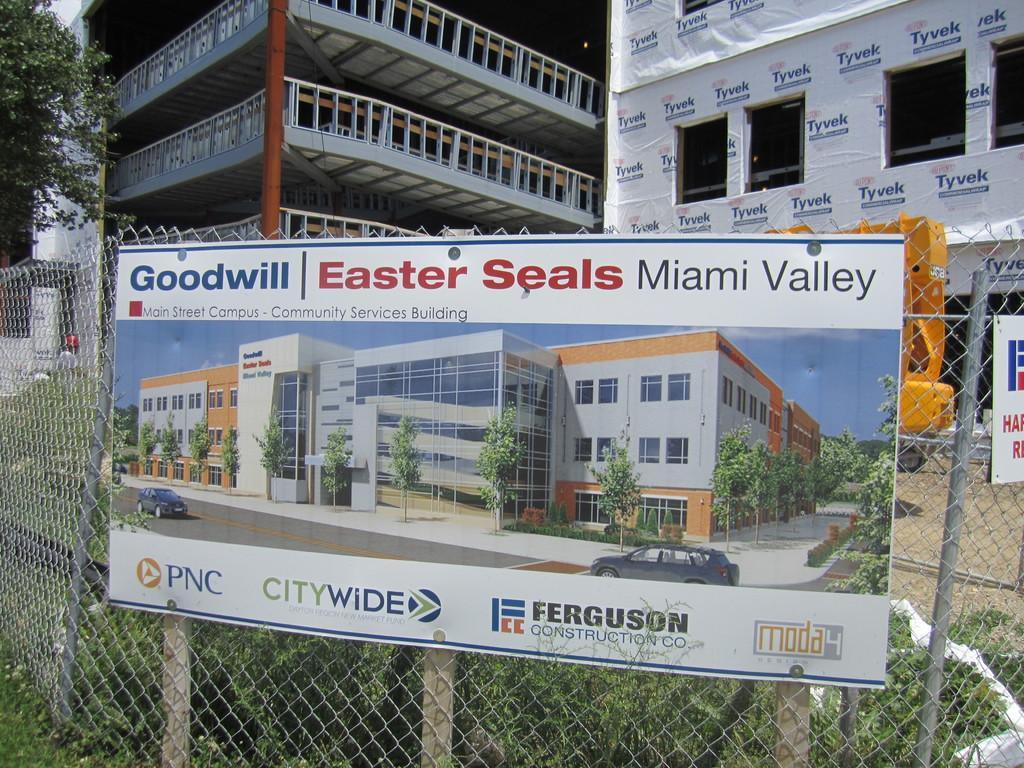Could you give a brief overview of what you see in this image? This image is taken outdoors. In the background there are two buildings with walls, grills, railings, pillars and windows. There is a sheet with a text on it. On the left side of the image there is a tree. In the middle of the image there is a mesh and there is a board with a text and a few images on it. There is a crane on the ground. There are a few plants. 